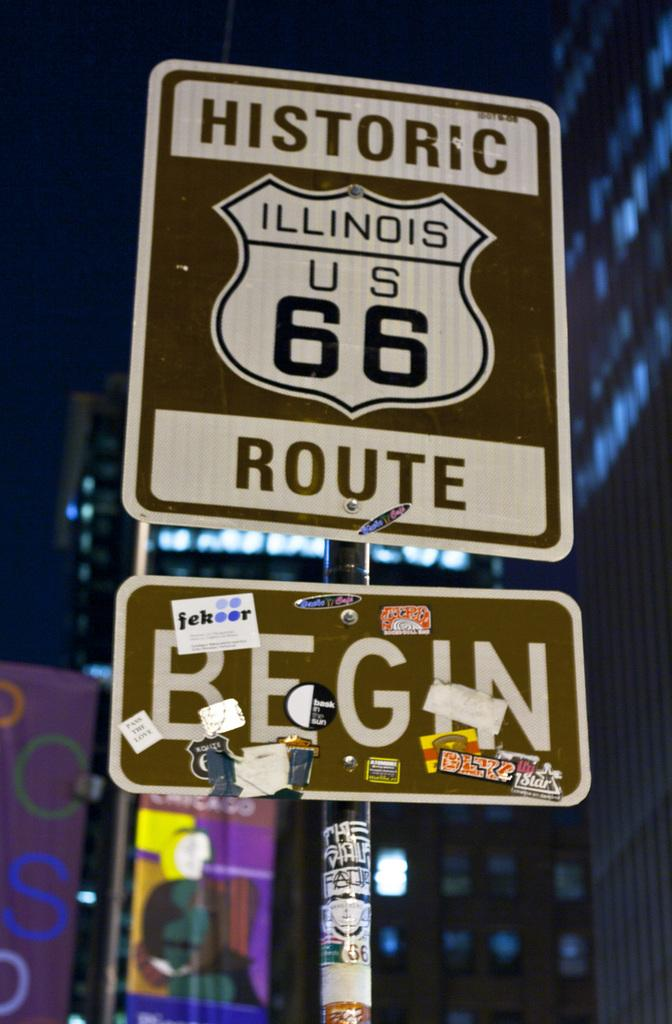<image>
Create a compact narrative representing the image presented. A sign for historic Illinois US 66 Route and Begin. 